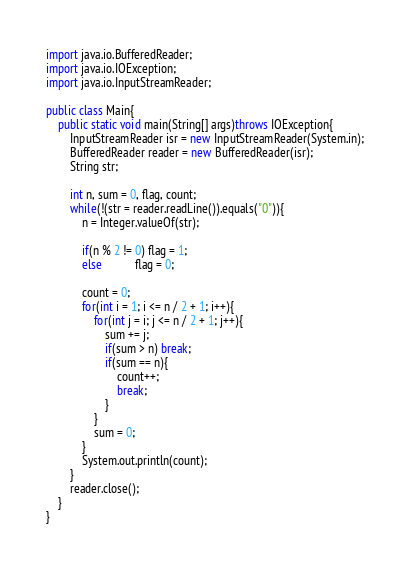Convert code to text. <code><loc_0><loc_0><loc_500><loc_500><_Java_>import java.io.BufferedReader;
import java.io.IOException;
import java.io.InputStreamReader;

public class Main{
	public static void main(String[] args)throws IOException{
		InputStreamReader isr = new InputStreamReader(System.in);
		BufferedReader reader = new BufferedReader(isr);
		String str;
		
		int n, sum = 0, flag, count;
		while(!(str = reader.readLine()).equals("0")){
			n = Integer.valueOf(str);
			
			if(n % 2 != 0) flag = 1;
			else           flag = 0; 
			
			count = 0;
			for(int i = 1; i <= n / 2 + 1; i++){
				for(int j = i; j <= n / 2 + 1; j++){
					sum += j;
					if(sum > n) break;
					if(sum == n){
						count++;
						break;
					}
				}
				sum = 0;
			}
			System.out.println(count);
		}
		reader.close();
	}
}</code> 